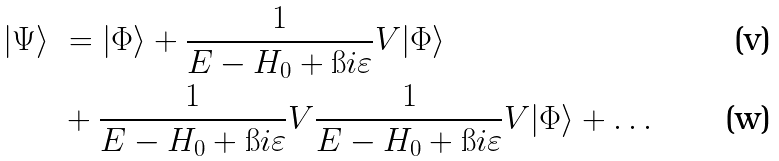<formula> <loc_0><loc_0><loc_500><loc_500>| \Psi \rangle \ & = | \Phi \rangle + \frac { 1 } { E - H _ { 0 } + \i i \varepsilon } V | \Phi \rangle \\ & + \frac { 1 } { E - H _ { 0 } + \i i \varepsilon } V \frac { 1 } { E - H _ { 0 } + \i i \varepsilon } V | \Phi \rangle + \hdots</formula> 